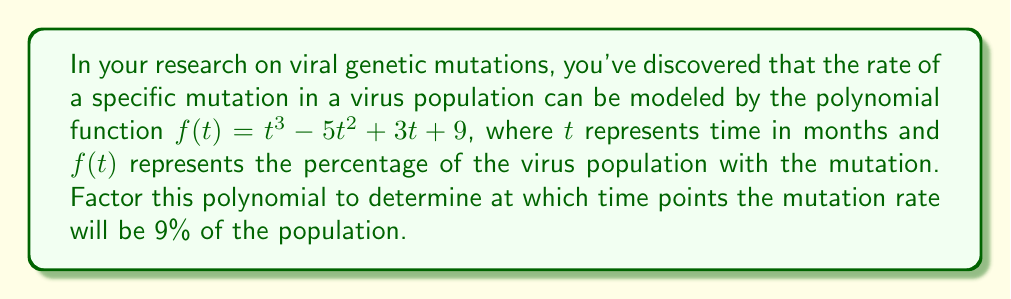Teach me how to tackle this problem. To solve this problem, we need to factor the polynomial $f(t) = t^3 - 5t^2 + 3t + 9$ and find the roots of the equation $f(t) = 9$. Let's approach this step-by-step:

1) First, we set up the equation:
   $t^3 - 5t^2 + 3t + 9 = 9$

2) Subtract 9 from both sides:
   $t^3 - 5t^2 + 3t = 0$

3) Factor out the greatest common factor:
   $t(t^2 - 5t + 3) = 0$

4) Now we can use the zero product property. Either $t = 0$ or $t^2 - 5t + 3 = 0$

5) For the quadratic part, we can use the quadratic formula or factoring. Let's factor:
   $t^2 - 5t + 3 = (t - 3)(t - 2)$

6) So our fully factored equation is:
   $t(t - 3)(t - 2) = 0$

7) The solutions to this equation are the values of $t$ where $f(t) = 9$:
   $t = 0$, $t = 3$, or $t = 2$

These solutions represent the time points (in months) when the mutation rate will be 9% of the virus population.
Answer: The mutation rate will be 9% of the virus population at $t = 0$, $t = 2$, and $t = 3$ months. 